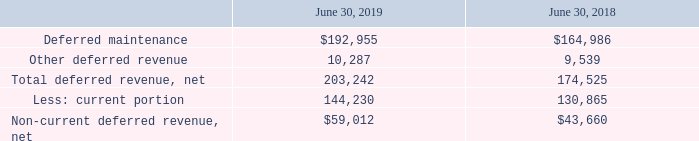Deferred Revenue
The following table summarizes contract liabilities which are shown as deferred revenue (in thousands):
Total deferred revenue increased primarily due to the extended duration period of new maintenance contracts during fiscal year 2019.
Which years does the table provide information for the company's contract liabilities? 2019, 2018. What was the net total deferred revenue in 2019?
Answer scale should be: thousand. 203,242. What was the other deferred revenue in 2018?
Answer scale should be: thousand. 9,539. How many years did Other deferred revenue exceed $10,000 thousand? 2019
Answer: 1. What was the change in the amount of Deferred maintenance between 2018 and 2019?
Answer scale should be: thousand. 192,955-164,986
Answer: 27969. What was the percentage change in the net Non-current deferred revenue between 2018 and 2019?
Answer scale should be: percent. (59,012-43,660)/43,660
Answer: 35.16. 